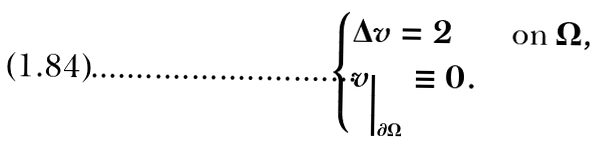Convert formula to latex. <formula><loc_0><loc_0><loc_500><loc_500>\begin{cases} \Delta v = 2 & \text {on $\Omega$} , \\ v _ { \Big | _ { \partial \Omega } } \equiv 0 . \end{cases}</formula> 